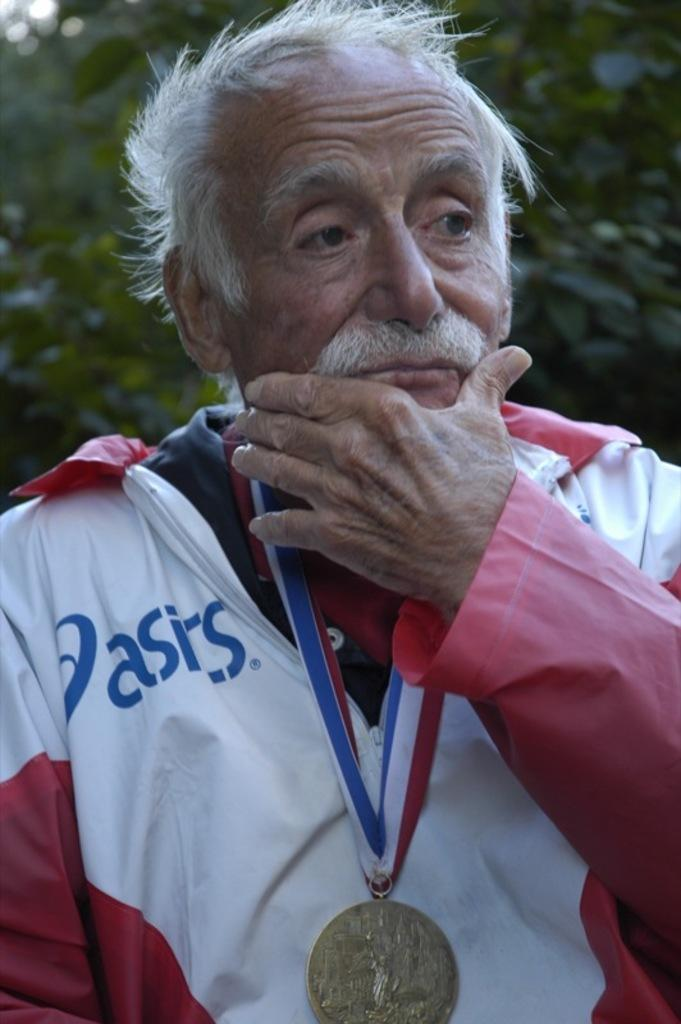<image>
Share a concise interpretation of the image provided. Old Man wearing Asics Jacket wearing a Medallion along his neck. 